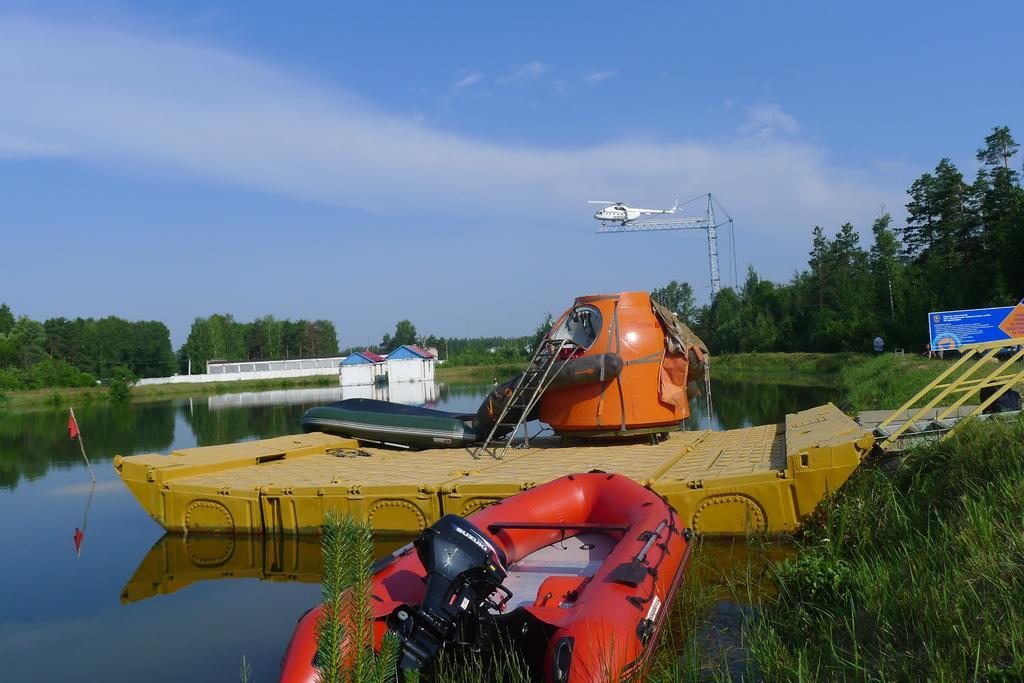In one or two sentences, can you explain what this image depicts? In this picture we can see boats, plants, rods, ladder, flag, banner, helicopter, tower, houses, fence, trees, water and some objects and a person standing and in the background we can see the sky. 